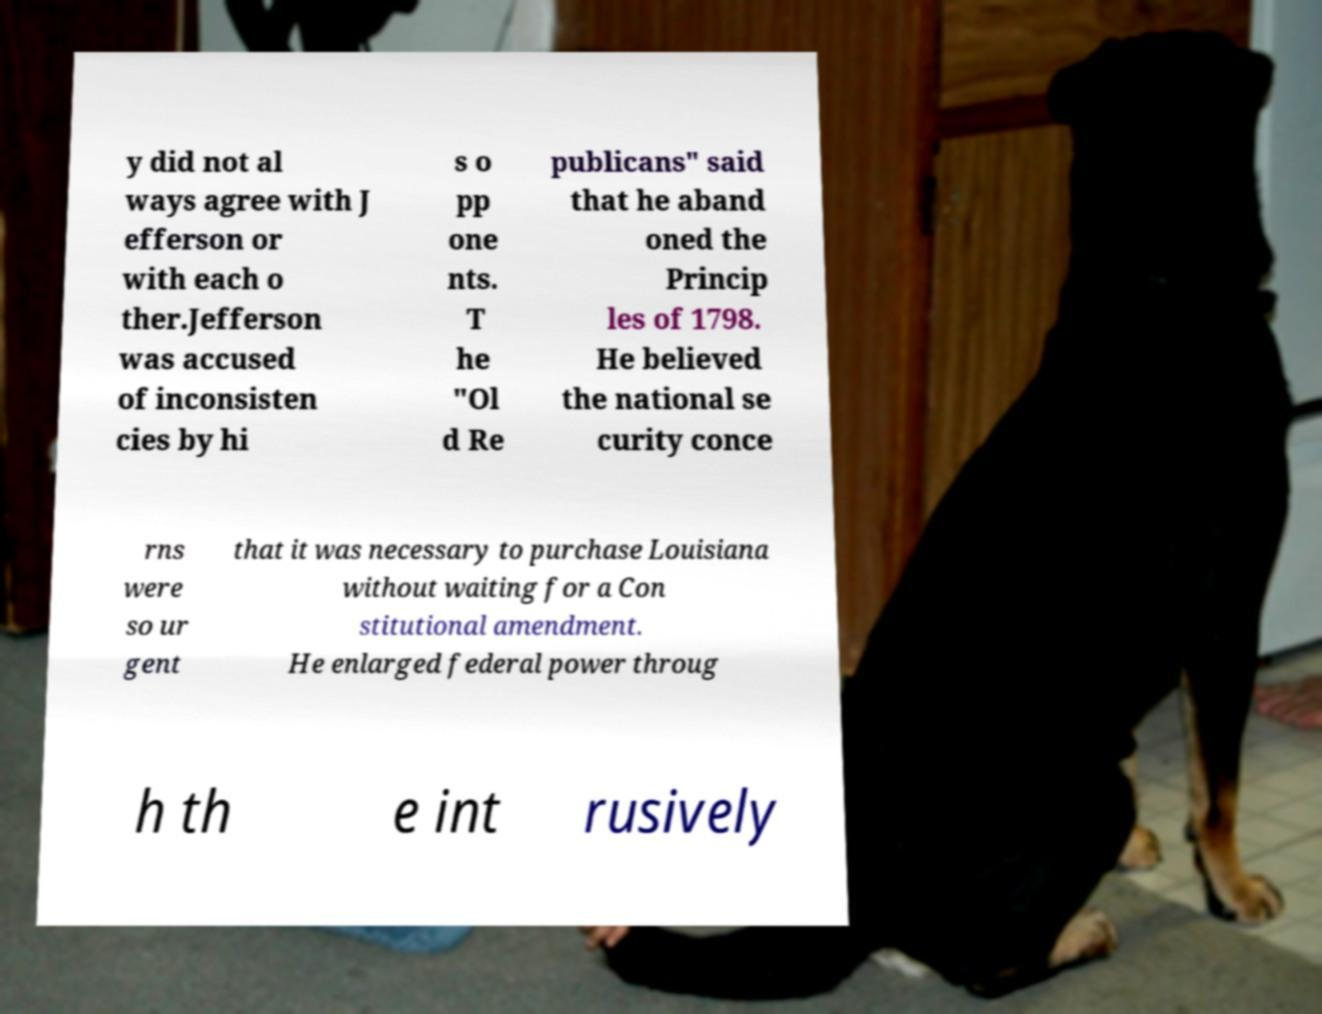Can you read and provide the text displayed in the image?This photo seems to have some interesting text. Can you extract and type it out for me? y did not al ways agree with J efferson or with each o ther.Jefferson was accused of inconsisten cies by hi s o pp one nts. T he "Ol d Re publicans" said that he aband oned the Princip les of 1798. He believed the national se curity conce rns were so ur gent that it was necessary to purchase Louisiana without waiting for a Con stitutional amendment. He enlarged federal power throug h th e int rusively 